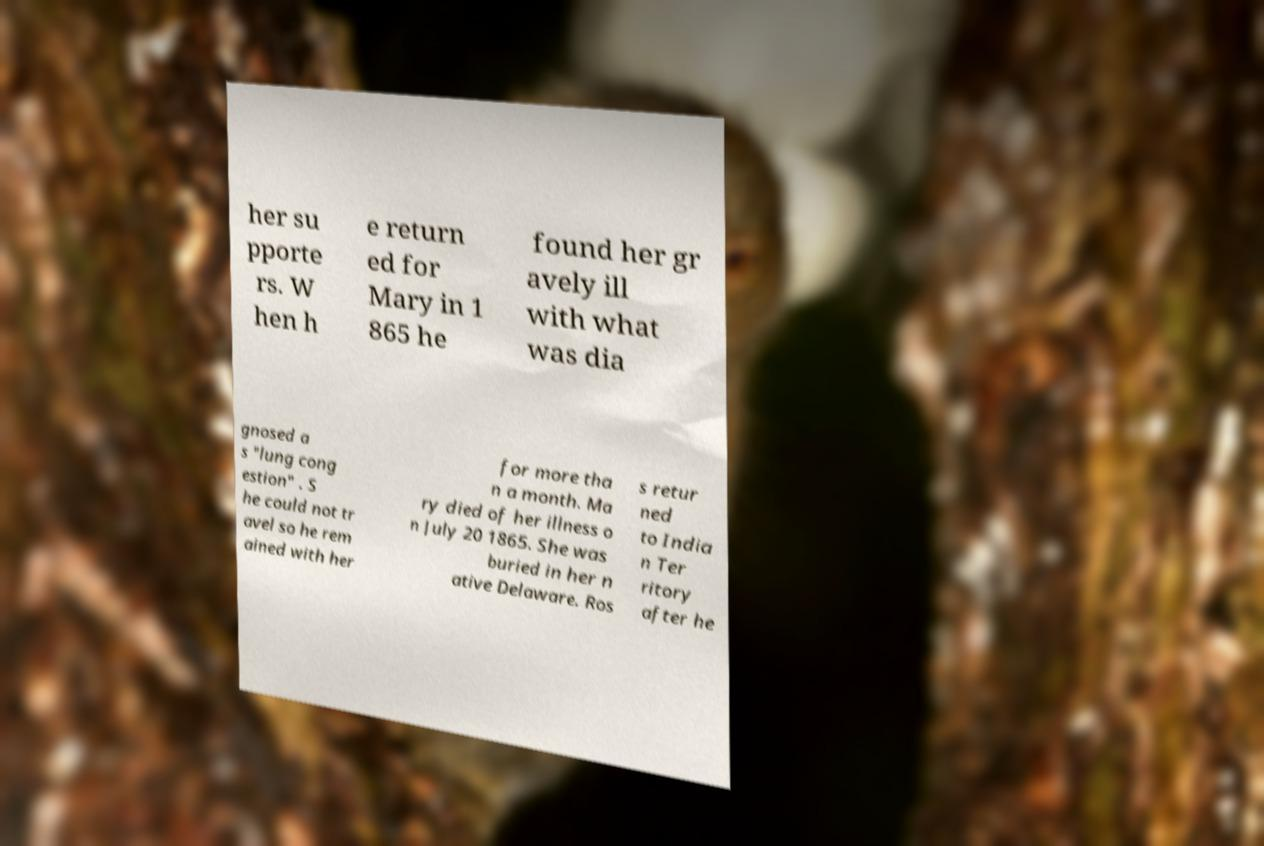For documentation purposes, I need the text within this image transcribed. Could you provide that? her su pporte rs. W hen h e return ed for Mary in 1 865 he found her gr avely ill with what was dia gnosed a s "lung cong estion" . S he could not tr avel so he rem ained with her for more tha n a month. Ma ry died of her illness o n July 20 1865. She was buried in her n ative Delaware. Ros s retur ned to India n Ter ritory after he 